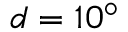Convert formula to latex. <formula><loc_0><loc_0><loc_500><loc_500>d = 1 0 ^ { \circ }</formula> 